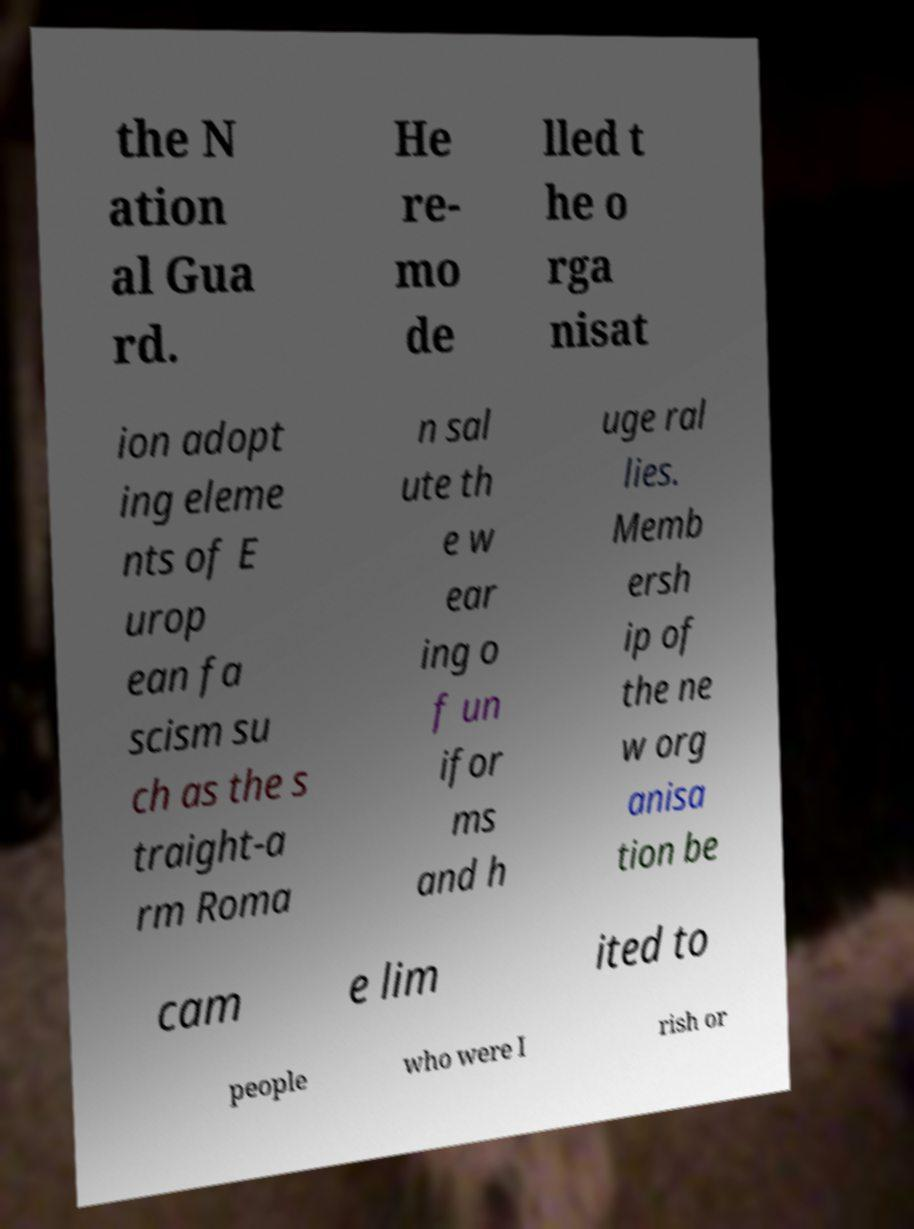There's text embedded in this image that I need extracted. Can you transcribe it verbatim? the N ation al Gua rd. He re- mo de lled t he o rga nisat ion adopt ing eleme nts of E urop ean fa scism su ch as the s traight-a rm Roma n sal ute th e w ear ing o f un ifor ms and h uge ral lies. Memb ersh ip of the ne w org anisa tion be cam e lim ited to people who were I rish or 